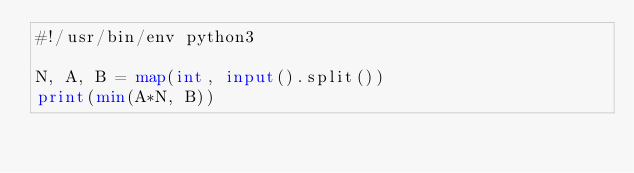<code> <loc_0><loc_0><loc_500><loc_500><_Python_>#!/usr/bin/env python3

N, A, B = map(int, input().split())
print(min(A*N, B))</code> 